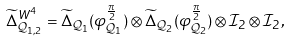Convert formula to latex. <formula><loc_0><loc_0><loc_500><loc_500>\widetilde { \Delta } ^ { W ^ { 4 } } _ { \mathcal { Q } _ { 1 , 2 } } = \widetilde { \Delta } _ { \mathcal { Q } _ { 1 } } ( \varphi ^ { \frac { \pi } { 2 } } _ { \mathcal { Q } _ { 1 } } ) \otimes \widetilde { \Delta } _ { \mathcal { Q } _ { 2 } } ( \varphi ^ { \frac { \pi } { 2 } } _ { \mathcal { Q } _ { 2 } } ) \otimes \mathcal { I } _ { 2 } \otimes \mathcal { I } _ { 2 } ,</formula> 